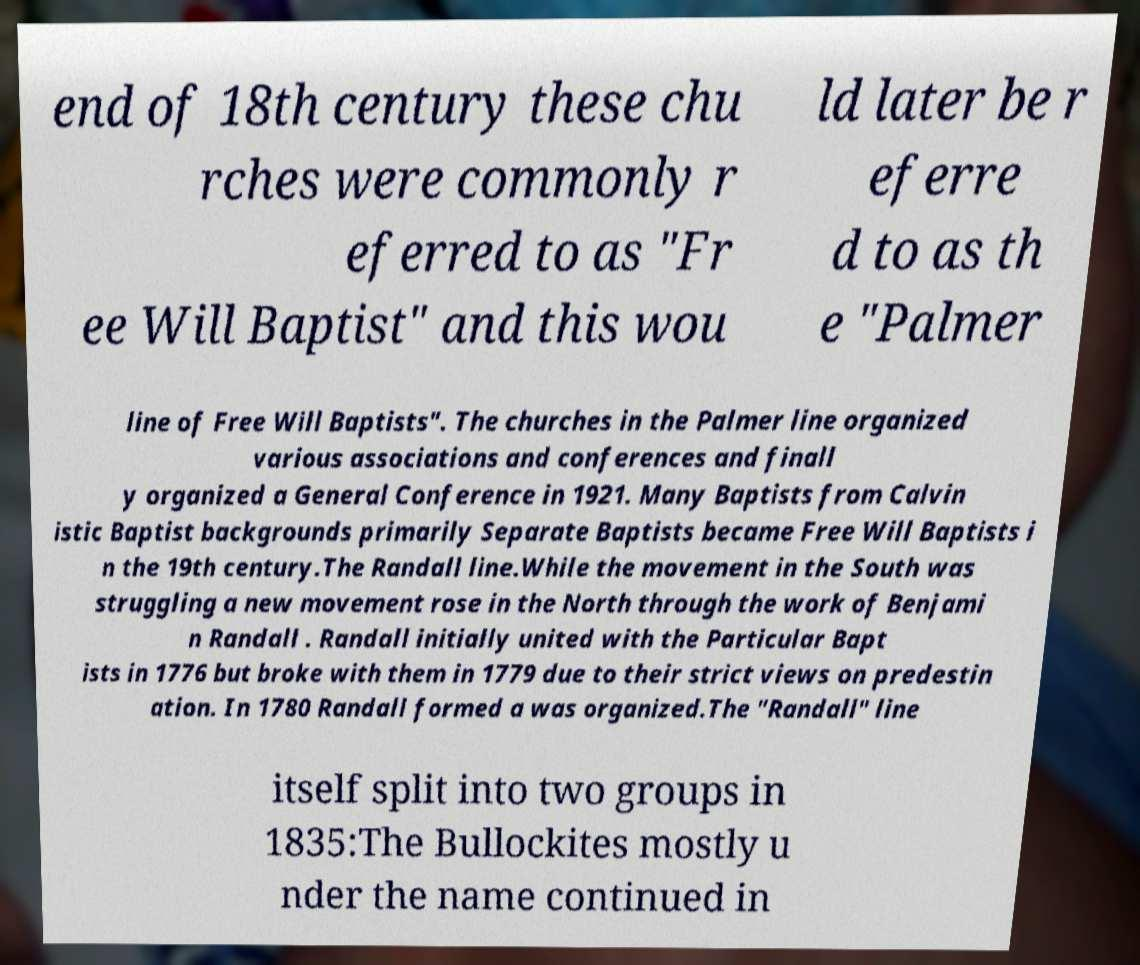Can you read and provide the text displayed in the image?This photo seems to have some interesting text. Can you extract and type it out for me? end of 18th century these chu rches were commonly r eferred to as "Fr ee Will Baptist" and this wou ld later be r eferre d to as th e "Palmer line of Free Will Baptists". The churches in the Palmer line organized various associations and conferences and finall y organized a General Conference in 1921. Many Baptists from Calvin istic Baptist backgrounds primarily Separate Baptists became Free Will Baptists i n the 19th century.The Randall line.While the movement in the South was struggling a new movement rose in the North through the work of Benjami n Randall . Randall initially united with the Particular Bapt ists in 1776 but broke with them in 1779 due to their strict views on predestin ation. In 1780 Randall formed a was organized.The "Randall" line itself split into two groups in 1835:The Bullockites mostly u nder the name continued in 